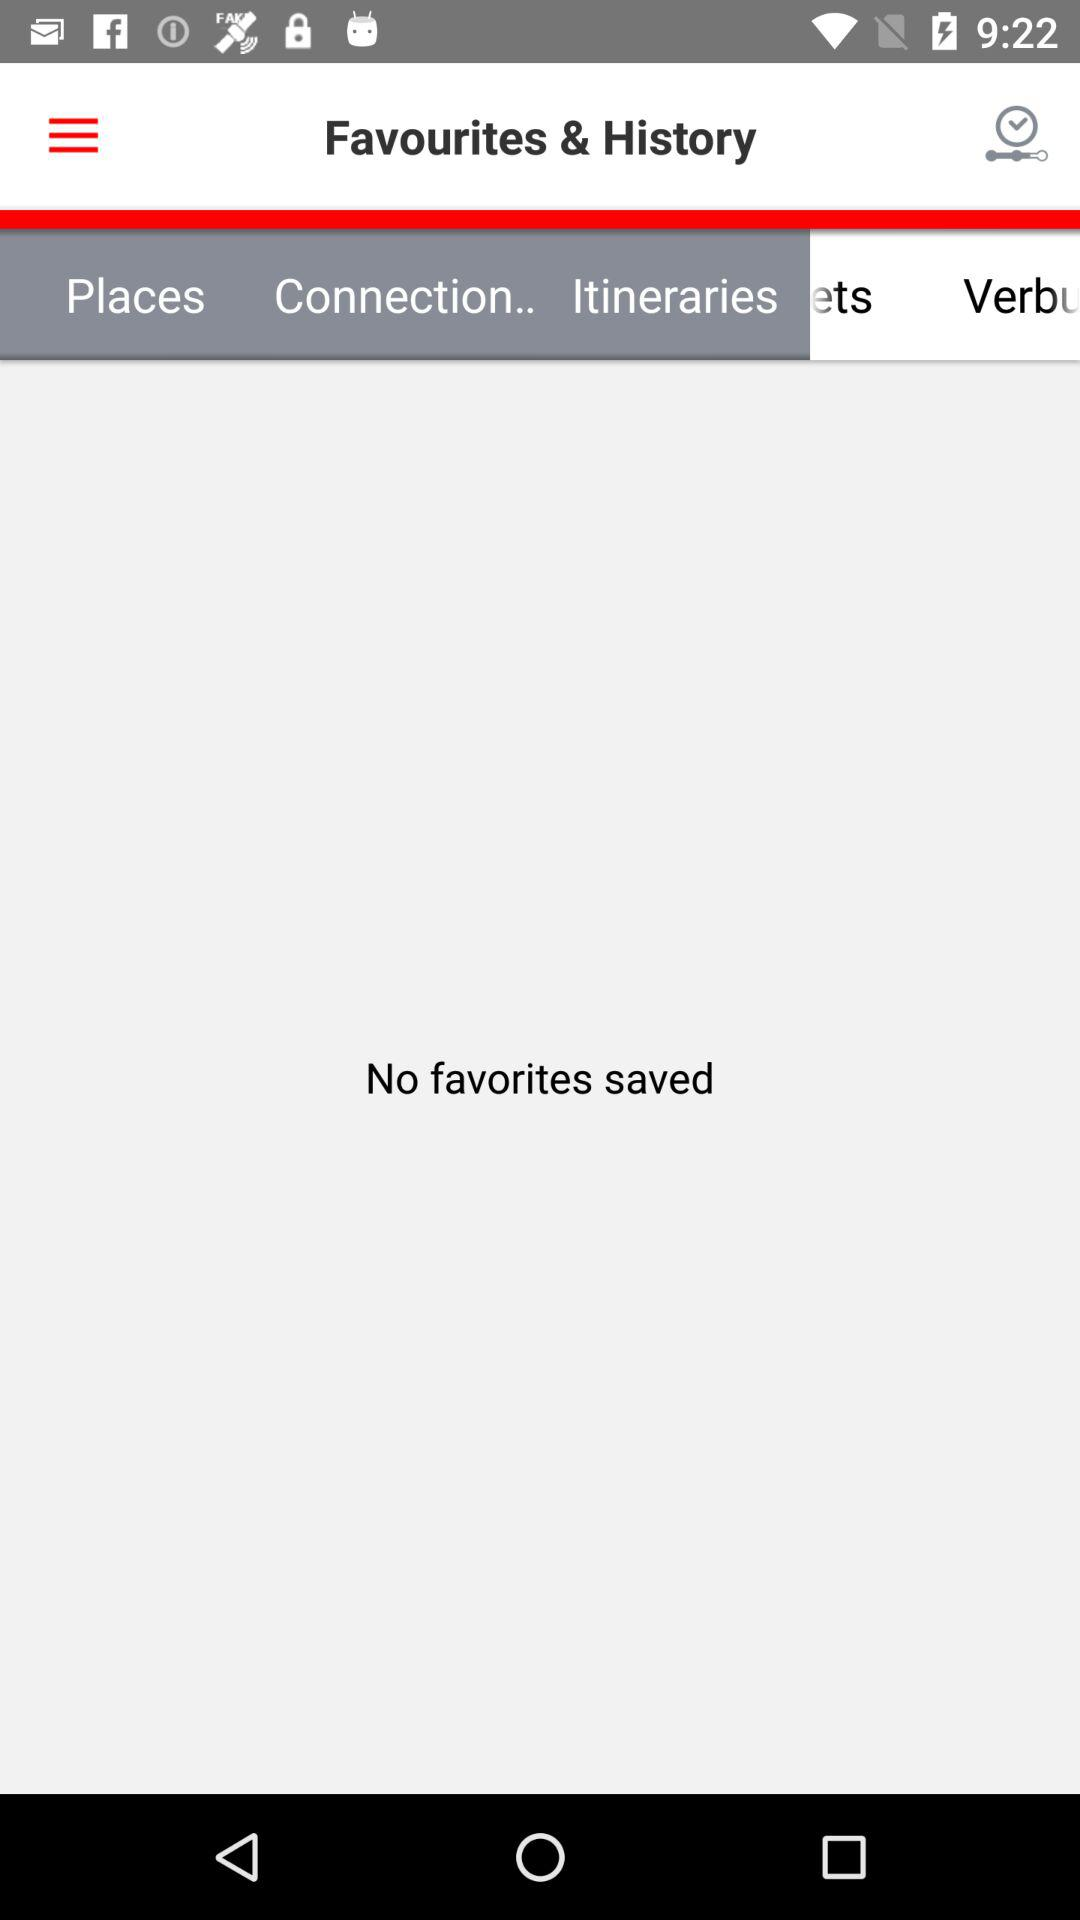How many favorites are saved? There are no favorites saved. 